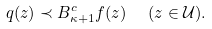<formula> <loc_0><loc_0><loc_500><loc_500>q ( z ) \prec B _ { \kappa + 1 } ^ { c } f ( z ) \text { \ \ } ( z \in { \mathcal { U } } ) .</formula> 